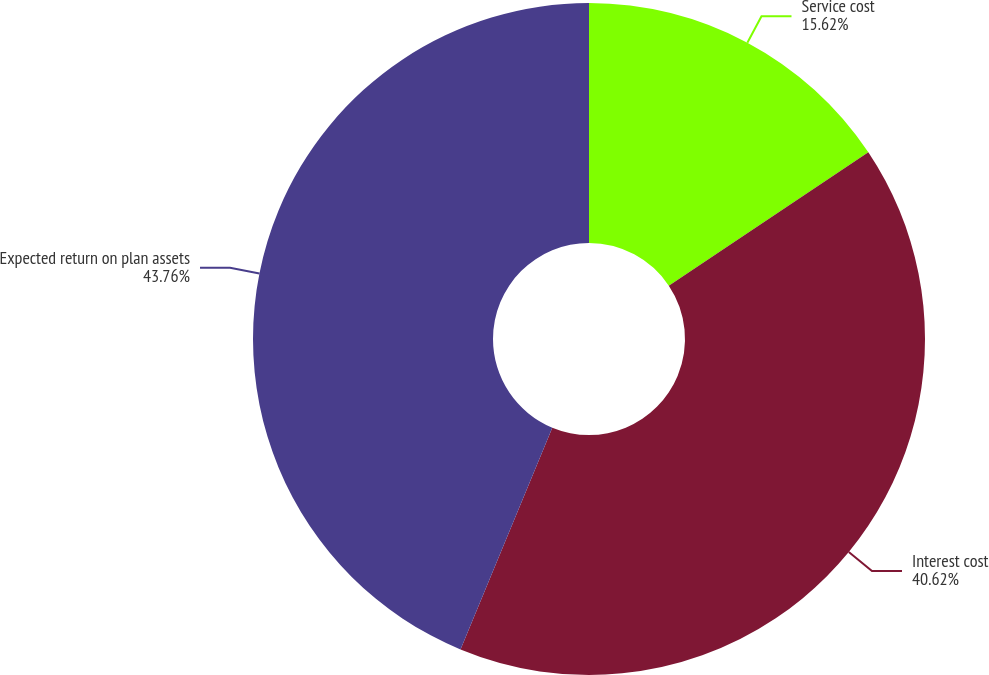Convert chart to OTSL. <chart><loc_0><loc_0><loc_500><loc_500><pie_chart><fcel>Service cost<fcel>Interest cost<fcel>Expected return on plan assets<nl><fcel>15.62%<fcel>40.62%<fcel>43.75%<nl></chart> 